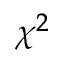Convert formula to latex. <formula><loc_0><loc_0><loc_500><loc_500>\chi ^ { 2 }</formula> 